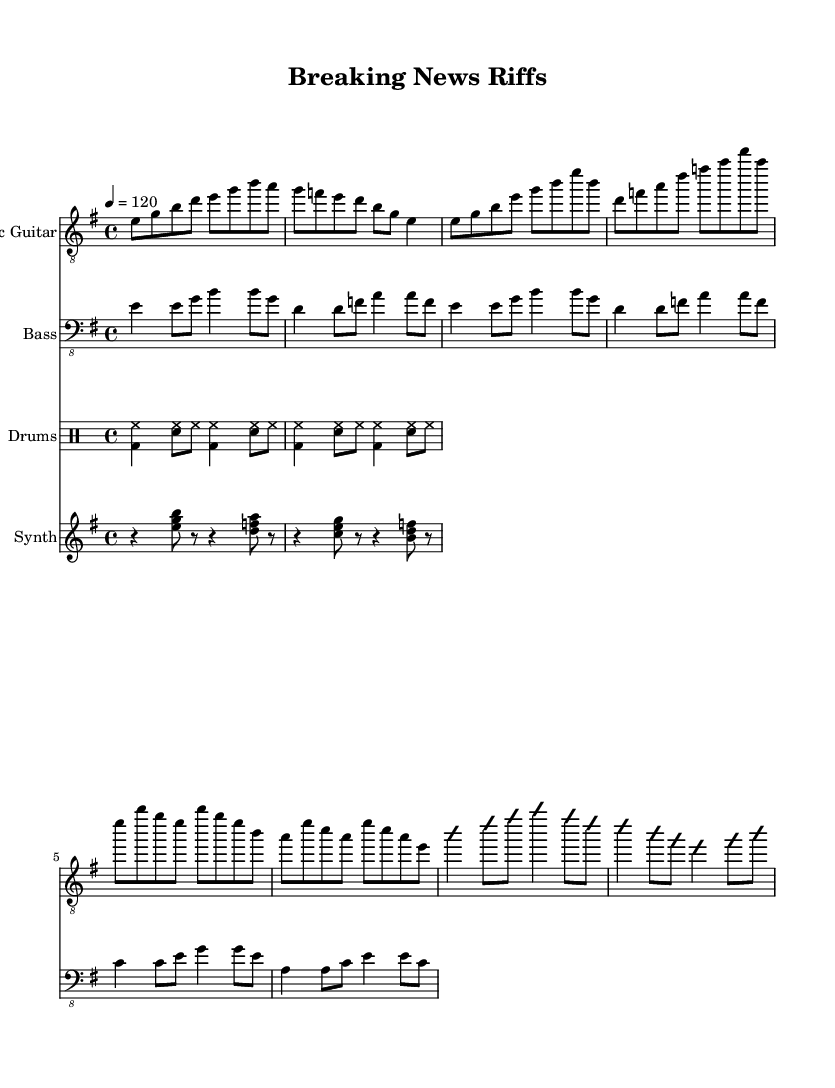What is the key signature of this music? The key signature is E minor, which has one sharp (F#).
Answer: E minor What is the time signature of this music? The time signature is 4/4, which means there are four beats in each measure.
Answer: 4/4 What is the tempo marking indicated in this sheet music? The tempo marking indicates a tempo of 120 beats per minute, commonly referred to as “moderato” in musical terms.
Answer: 120 Which instrument section has a guitar solo part? The electric guitar part explicitly includes a section labeled as "Guitar Solo" with notation for improvisation.
Answer: Electric Guitar How many measures are present in the verse section? The verse section contains four measures, each with distinct melodic phrases set to a consistent time signature.
Answer: 4 What type of rhythm pattern is used in the drums part? The drums part employs a basic rock beat, characterized by a combination of bass drum and snare hits with hi-hat accompaniment.
Answer: Basic rock beat What is the overall genre of this composition? The composition combines elements of jazz and rock, specifically termed "Fusion," which is defined by its use of electric instrumentation and improvisation.
Answer: Fusion 